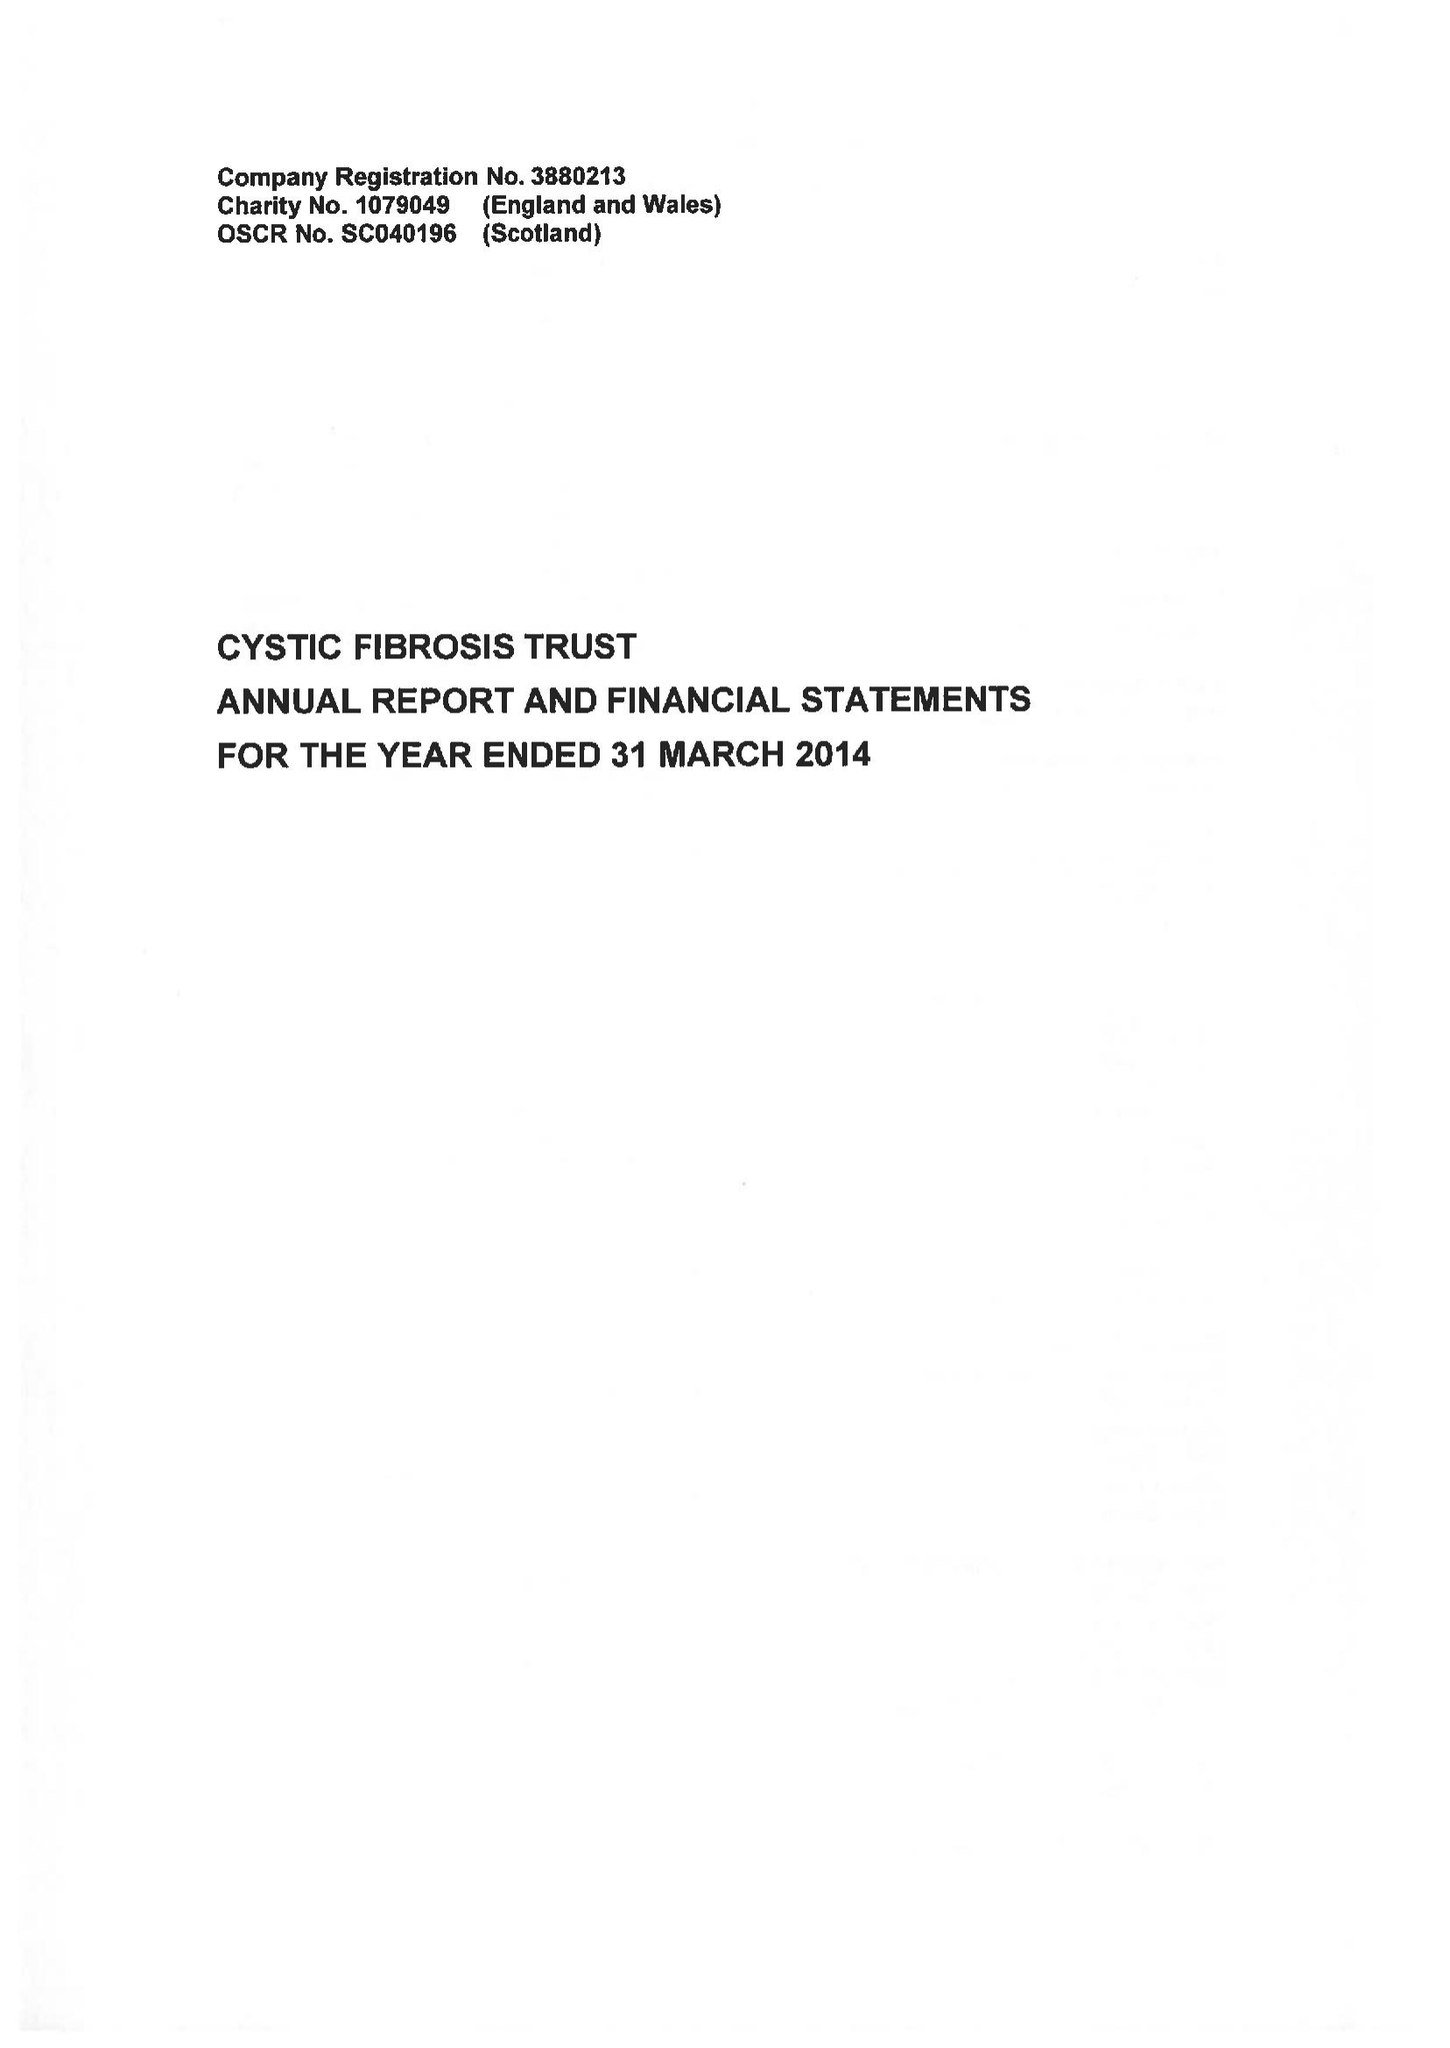What is the value for the report_date?
Answer the question using a single word or phrase. 2014-03-31 